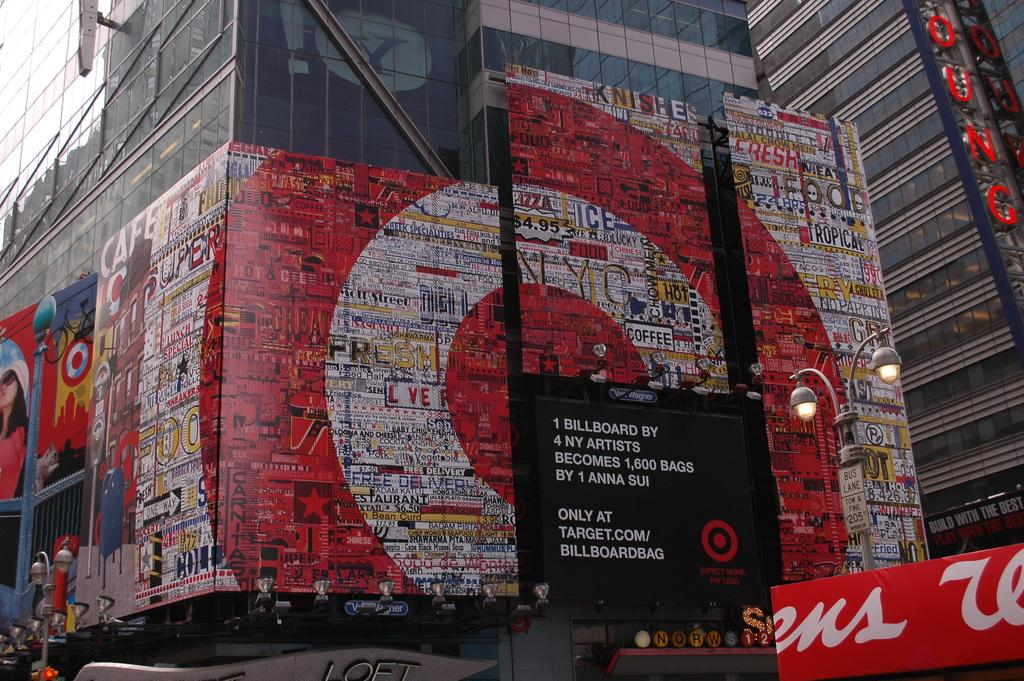Provide a one-sentence caption for the provided image. A Target billboard that was created by 4 artists from New York. 